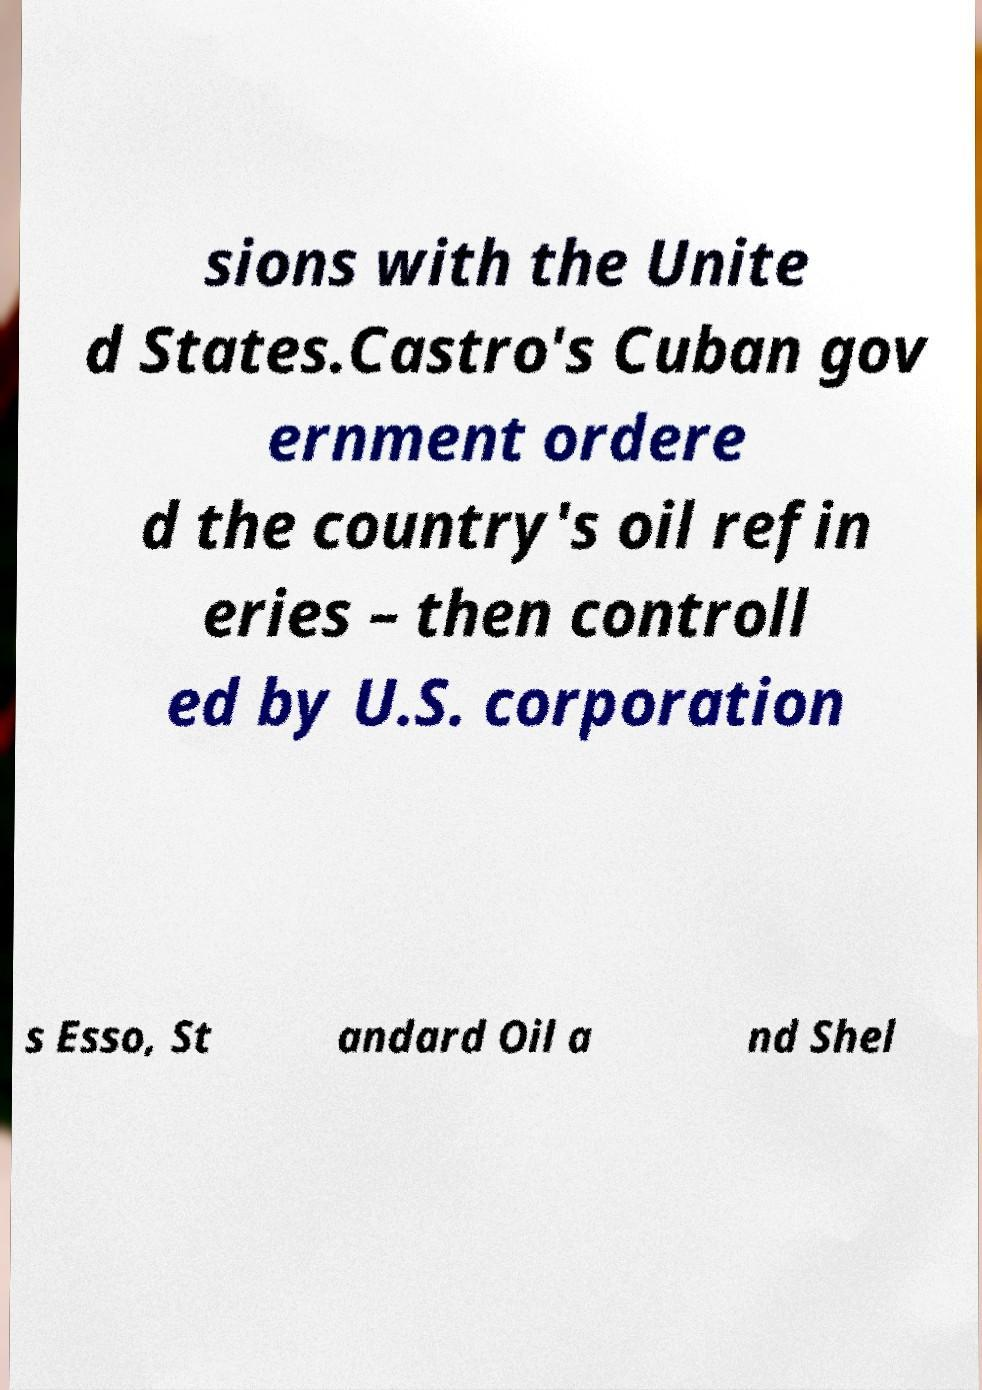For documentation purposes, I need the text within this image transcribed. Could you provide that? sions with the Unite d States.Castro's Cuban gov ernment ordere d the country's oil refin eries – then controll ed by U.S. corporation s Esso, St andard Oil a nd Shel 